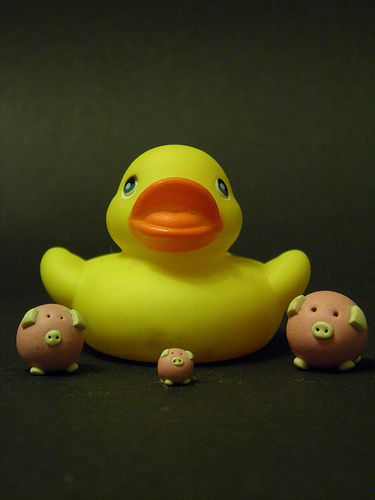<image>
Is the duck in front of the pig? No. The duck is not in front of the pig. The spatial positioning shows a different relationship between these objects. Where is the big in relation to the small? Is it to the right of the small? No. The big is not to the right of the small. The horizontal positioning shows a different relationship. 